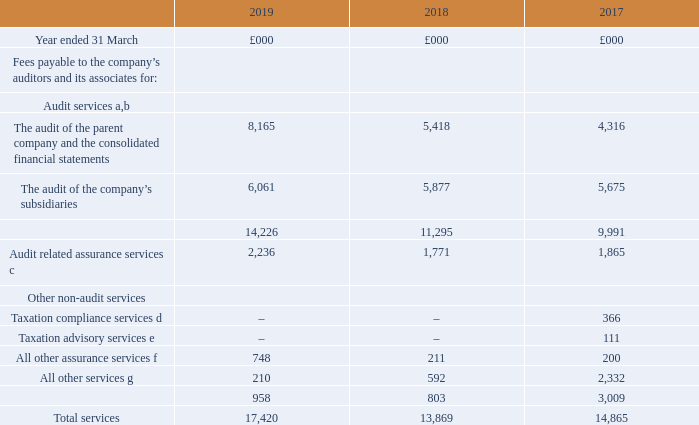9. Audit, audit related and other non-audit services  The following fees were paid or are payable to the company’s auditors, KPMG LLP and other firms in the KPMG network, for the year ended 31 March 2019. Figures in the table below for the years ended 31 March 2017 and 2018 are in respect of fees paid to the company’s previous auditors, PricewaterhouseCoopers LLP.
a Services in relation to the audit of the parent company and the consolidated financial statements, including fees for reports under section 404 of the Sarbanes-Oxley Act. This also includes fees payable for the statutory audits of the financial statements of subsidiary companies. This excludes amounts for the audit of BT Group Employee Share Ownership Trust and Ilford Trustees (Jersey) Limited amounting to £32,000.
b During the year a further £446,000 of fees were payable to PricewaterhouseCoopers LLP in relation to the audit of 2017/18 subsidiary accounts and the audit of our restated IAS 19 accounting valuation of retirement benefit obligations, which have not been included in the 2019 balances in the above table.
c Services in relation to other statutory filings or engagements that are required by law or regulation to be carried out by an appointed auditor. This includes fees for the review of interim results, the accrued fee for the audit of the group’s regulatory financial statements and reporting associated with the group’s US debt shelf registration. d Services relating to tax returns, tax audits, monitoring and enquiries.
e Fees payable for all taxation advisory services not falling within taxation compliance. All other assurance services include fees payable to KPMG LLP for agreed upon procedures performed on the estimated impact of the new IFRS 15 revenue accounting standard, which took effect from 1 April 2018 for the 2017/18 audit. g Fees payable for all non-audit services not covered above, principally comprising other advisory services.
f All other assurance services include fees payable to KPMG LLP for agreed upon procedures performed on the estimated impact of the new IFRS 15 revenue accounting standard, which took effect from 1 April 2018 for the 2017/18 audit.
g Fees payable for all non-audit services not covered above, principally comprising other advisory services.
What fees were payable to PricewaterhouseCoopers LLP in relation to the audit of 2017/18 subsidiary accounts? £446,000. What was The audit of the parent company and the consolidated financial statements in 2019?
Answer scale should be: thousand. 8,165. What was the  All other services in 2019?
Answer scale should be: thousand. 210. What was the change in the The audit of the parent company and the consolidated financial statements from 2018 to 2019?
Answer scale should be: thousand. 8,165 - 5,418
Answer: 2747. What is the average The audit of the company’s subsidiaries from 2017-2019?
Answer scale should be: thousand. (6,061 + 5,877 + 5,675) / 3
Answer: 5871. What is the percentage change in the Total services from 2018 to 2019?
Answer scale should be: percent. 17,420 / 13,869 - 1
Answer: 25.6. 